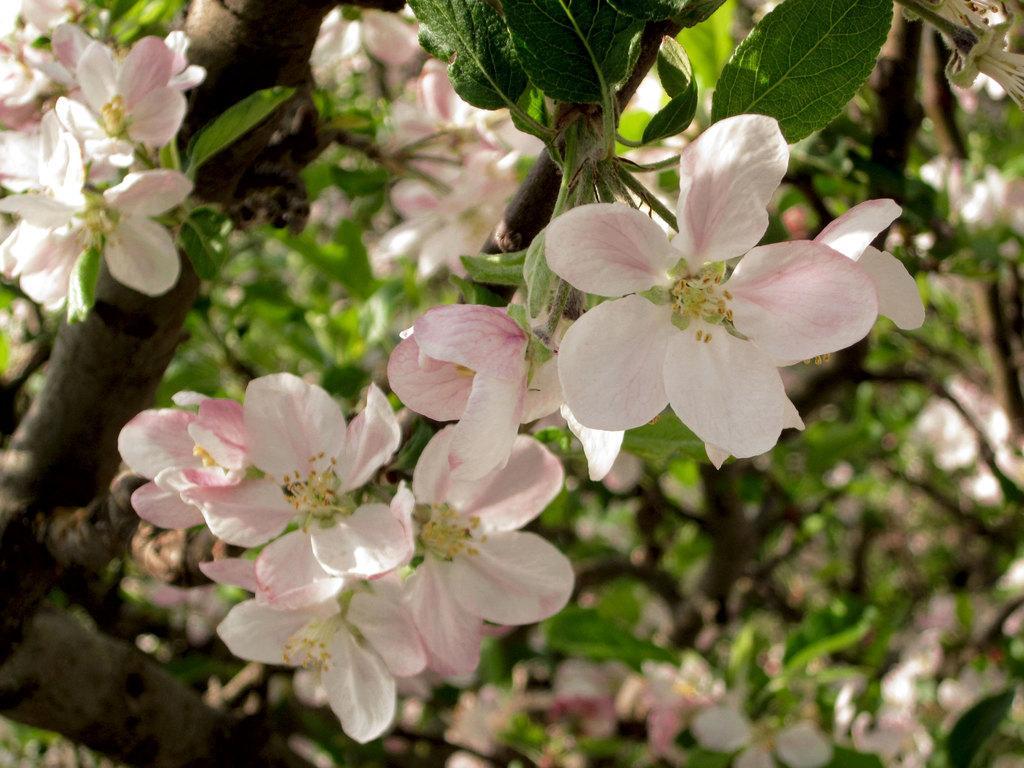Can you describe this image briefly? In this image we can see the branch of a tree. Here we can see the flowers and here we can see the green leaves. 